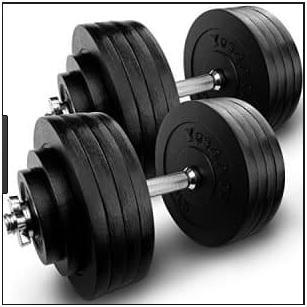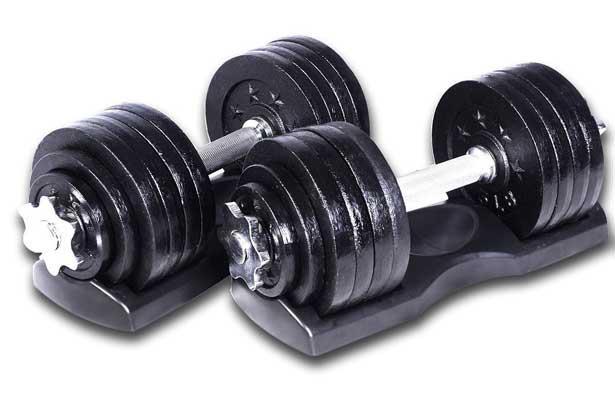The first image is the image on the left, the second image is the image on the right. Assess this claim about the two images: "One image shows a row of at least four black barbells on a black rack.". Correct or not? Answer yes or no. No. The first image is the image on the left, the second image is the image on the right. For the images displayed, is the sentence "In one of the images, there is an assembled dumbbell with extra plates next to it." factually correct? Answer yes or no. No. 